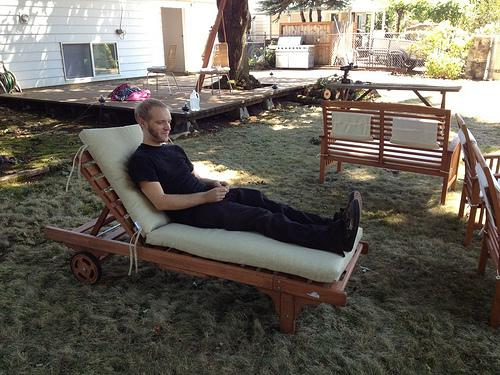Question: where is the chairs?
Choices:
A. In the grass.
B. In the house.
C. On the concrete.
D. On the street.
Answer with the letter. Answer: A Question: who is sitting on the chair?
Choices:
A. Man.
B. Woman.
C. Two children.
D. A couple.
Answer with the letter. Answer: A Question: how many benches?
Choices:
A. One.
B. Three.
C. Four.
D. Two.
Answer with the letter. Answer: D 